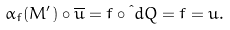<formula> <loc_0><loc_0><loc_500><loc_500>\alpha _ { f } ( M ^ { \prime } ) \circ \overline { u } = f \circ \i d { Q } = f = u .</formula> 